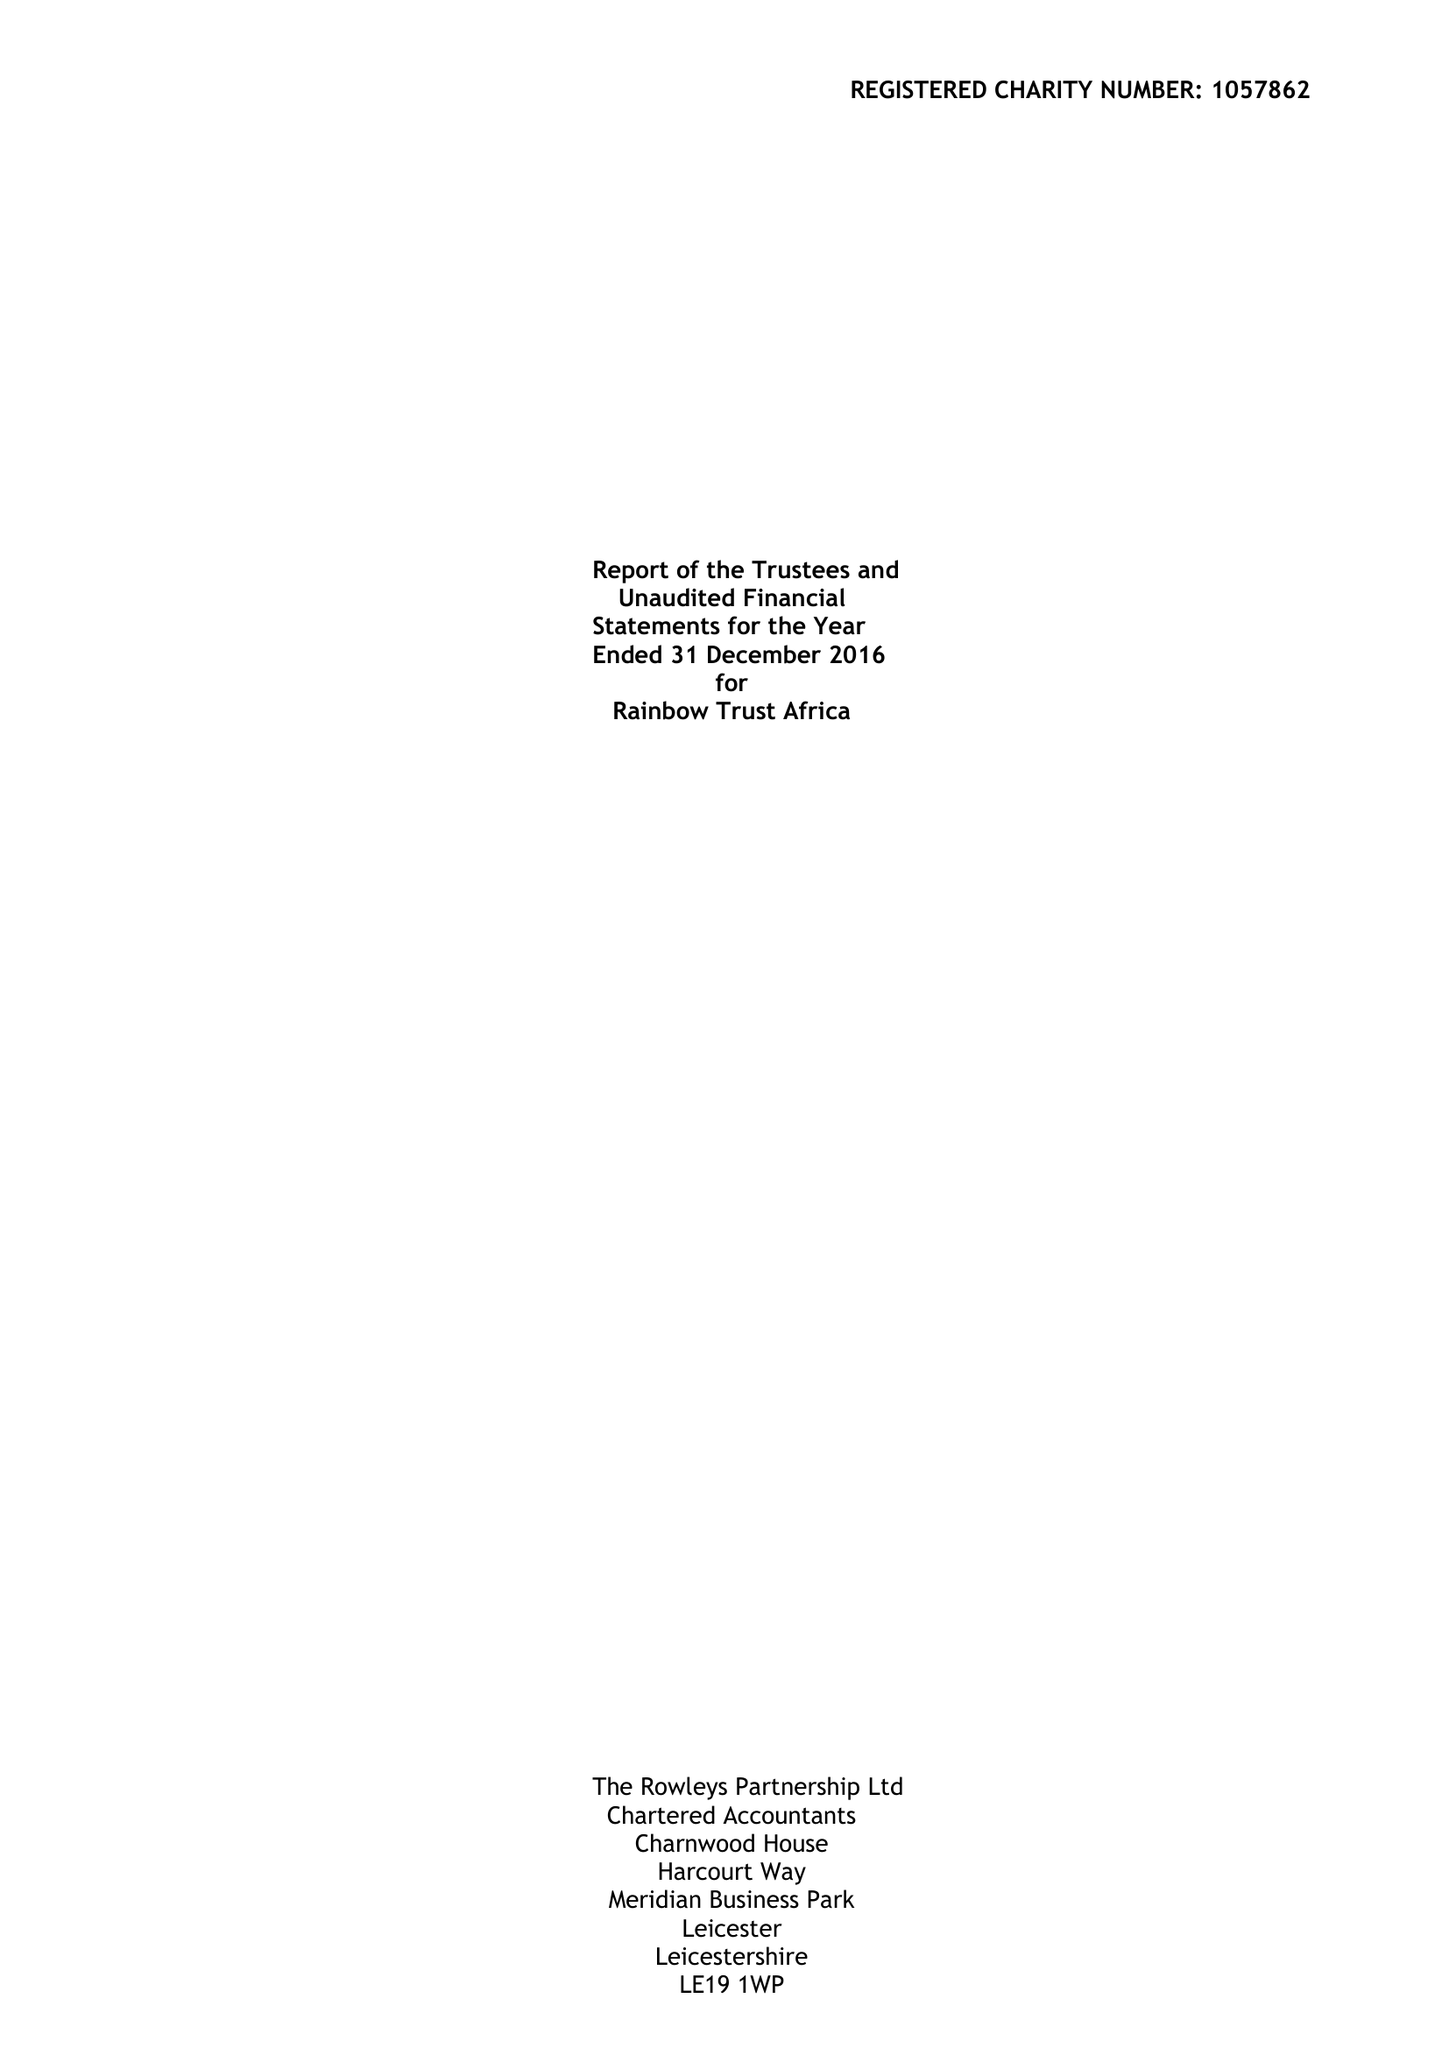What is the value for the charity_name?
Answer the question using a single word or phrase. Rainbow Trust Africa 